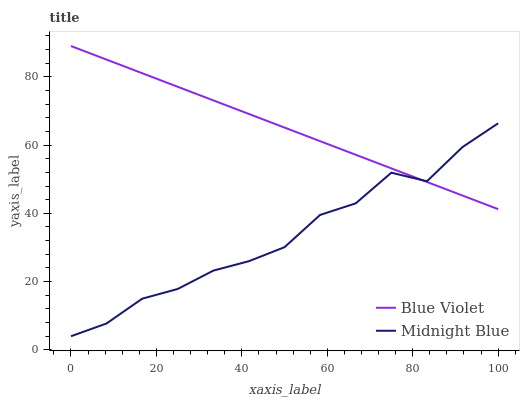Does Midnight Blue have the minimum area under the curve?
Answer yes or no. Yes. Does Blue Violet have the maximum area under the curve?
Answer yes or no. Yes. Does Blue Violet have the minimum area under the curve?
Answer yes or no. No. Is Blue Violet the smoothest?
Answer yes or no. Yes. Is Midnight Blue the roughest?
Answer yes or no. Yes. Is Blue Violet the roughest?
Answer yes or no. No. Does Midnight Blue have the lowest value?
Answer yes or no. Yes. Does Blue Violet have the lowest value?
Answer yes or no. No. Does Blue Violet have the highest value?
Answer yes or no. Yes. Does Midnight Blue intersect Blue Violet?
Answer yes or no. Yes. Is Midnight Blue less than Blue Violet?
Answer yes or no. No. Is Midnight Blue greater than Blue Violet?
Answer yes or no. No. 